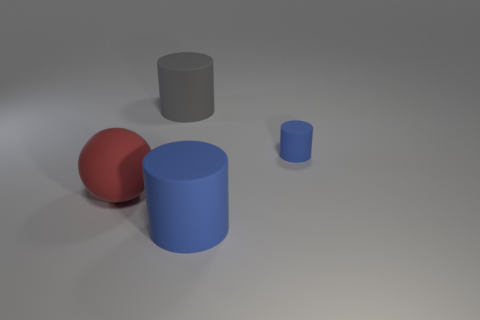There is a blue matte object that is behind the large cylinder right of the big gray matte cylinder; what is its shape?
Ensure brevity in your answer.  Cylinder. Is there anything else of the same color as the tiny matte thing?
Offer a terse response. Yes. There is a blue matte object that is left of the small matte cylinder; what shape is it?
Provide a succinct answer. Cylinder. There is a big object that is both behind the large blue cylinder and in front of the large gray matte object; what is its shape?
Keep it short and to the point. Sphere. How many brown things are small things or balls?
Make the answer very short. 0. Do the large sphere to the left of the tiny rubber cylinder and the small rubber cylinder have the same color?
Your answer should be compact. No. There is a thing that is left of the rubber cylinder behind the small blue object; what is its size?
Your answer should be compact. Large. What material is the gray object that is the same size as the red thing?
Make the answer very short. Rubber. How many other objects are there of the same size as the gray thing?
Your answer should be very brief. 2. How many blocks are either small things or gray objects?
Offer a terse response. 0. 